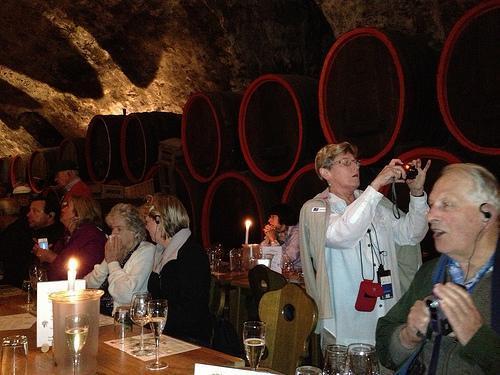How many people are holding up cameras?
Give a very brief answer. 2. 